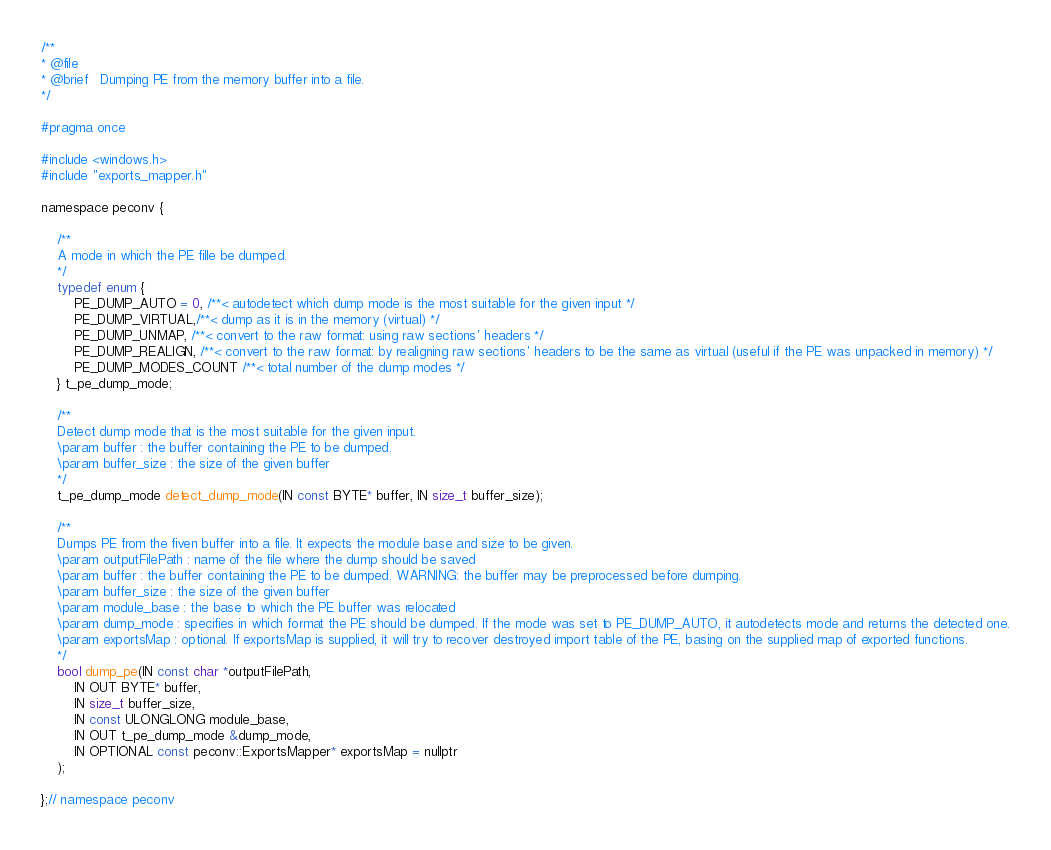<code> <loc_0><loc_0><loc_500><loc_500><_C_>/**
* @file
* @brief   Dumping PE from the memory buffer into a file.
*/

#pragma once

#include <windows.h>
#include "exports_mapper.h"

namespace peconv {

    /**
    A mode in which the PE fille be dumped.
    */
    typedef enum {
        PE_DUMP_AUTO = 0, /**< autodetect which dump mode is the most suitable for the given input */
        PE_DUMP_VIRTUAL,/**< dump as it is in the memory (virtual) */
        PE_DUMP_UNMAP, /**< convert to the raw format: using raw sections' headers */
        PE_DUMP_REALIGN, /**< convert to the raw format: by realigning raw sections' headers to be the same as virtual (useful if the PE was unpacked in memory) */
        PE_DUMP_MODES_COUNT /**< total number of the dump modes */
    } t_pe_dump_mode;

    /**
    Detect dump mode that is the most suitable for the given input.
    \param buffer : the buffer containing the PE to be dumped.
    \param buffer_size : the size of the given buffer
    */
    t_pe_dump_mode detect_dump_mode(IN const BYTE* buffer, IN size_t buffer_size);

    /**
    Dumps PE from the fiven buffer into a file. It expects the module base and size to be given. 
    \param outputFilePath : name of the file where the dump should be saved
    \param buffer : the buffer containing the PE to be dumped. WARNING: the buffer may be preprocessed before dumping.
    \param buffer_size : the size of the given buffer
    \param module_base : the base to which the PE buffer was relocated
    \param dump_mode : specifies in which format the PE should be dumped. If the mode was set to PE_DUMP_AUTO, it autodetects mode and returns the detected one.
    \param exportsMap : optional. If exportsMap is supplied, it will try to recover destroyed import table of the PE, basing on the supplied map of exported functions.
    */
    bool dump_pe(IN const char *outputFilePath,
        IN OUT BYTE* buffer,
        IN size_t buffer_size,
        IN const ULONGLONG module_base,
        IN OUT t_pe_dump_mode &dump_mode,
        IN OPTIONAL const peconv::ExportsMapper* exportsMap = nullptr
    );

};// namespace peconv
</code> 